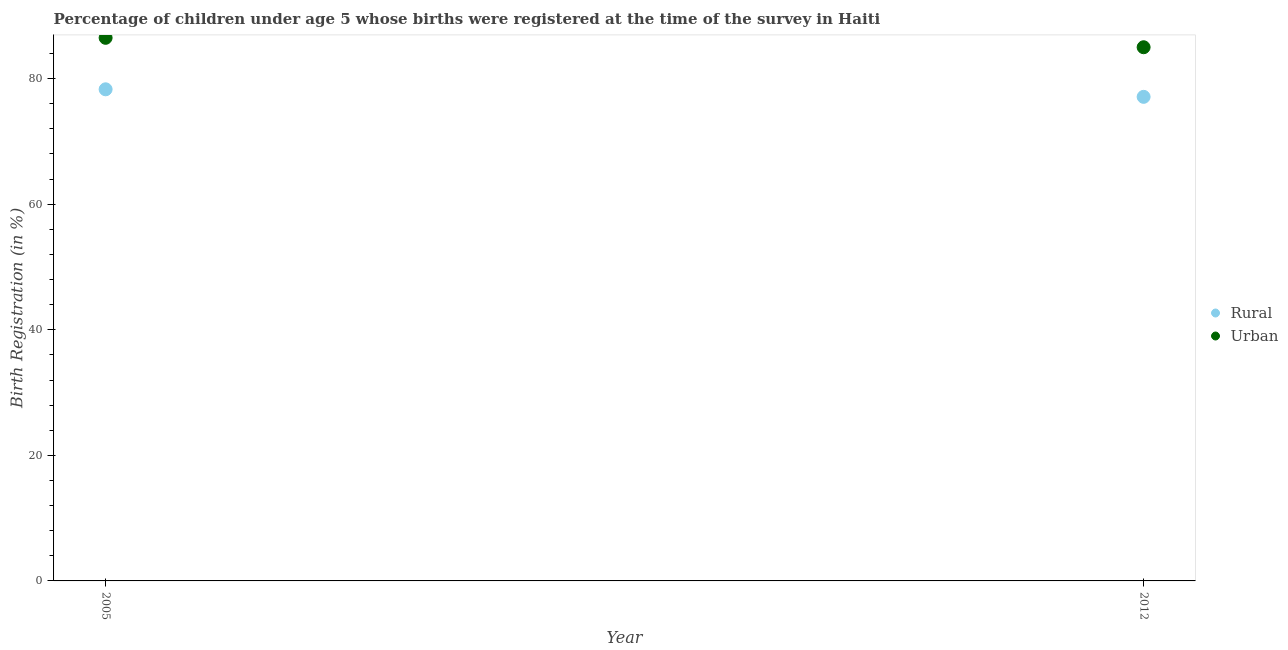Is the number of dotlines equal to the number of legend labels?
Offer a very short reply. Yes. What is the urban birth registration in 2012?
Keep it short and to the point. 85. Across all years, what is the maximum rural birth registration?
Ensure brevity in your answer.  78.3. In which year was the rural birth registration minimum?
Give a very brief answer. 2012. What is the total urban birth registration in the graph?
Provide a short and direct response. 171.5. What is the difference between the urban birth registration in 2005 and that in 2012?
Keep it short and to the point. 1.5. What is the difference between the urban birth registration in 2012 and the rural birth registration in 2005?
Provide a short and direct response. 6.7. What is the average urban birth registration per year?
Provide a succinct answer. 85.75. In the year 2012, what is the difference between the urban birth registration and rural birth registration?
Your response must be concise. 7.9. In how many years, is the rural birth registration greater than 44 %?
Your answer should be very brief. 2. What is the ratio of the rural birth registration in 2005 to that in 2012?
Your answer should be compact. 1.02. Is the rural birth registration in 2005 less than that in 2012?
Keep it short and to the point. No. Does the urban birth registration monotonically increase over the years?
Offer a very short reply. No. Is the rural birth registration strictly greater than the urban birth registration over the years?
Offer a terse response. No. How many years are there in the graph?
Provide a succinct answer. 2. What is the difference between two consecutive major ticks on the Y-axis?
Offer a terse response. 20. Does the graph contain grids?
Provide a succinct answer. No. Where does the legend appear in the graph?
Provide a succinct answer. Center right. How many legend labels are there?
Offer a very short reply. 2. How are the legend labels stacked?
Offer a terse response. Vertical. What is the title of the graph?
Make the answer very short. Percentage of children under age 5 whose births were registered at the time of the survey in Haiti. What is the label or title of the X-axis?
Provide a succinct answer. Year. What is the label or title of the Y-axis?
Offer a terse response. Birth Registration (in %). What is the Birth Registration (in %) of Rural in 2005?
Provide a succinct answer. 78.3. What is the Birth Registration (in %) of Urban in 2005?
Give a very brief answer. 86.5. What is the Birth Registration (in %) of Rural in 2012?
Offer a terse response. 77.1. What is the Birth Registration (in %) in Urban in 2012?
Your answer should be very brief. 85. Across all years, what is the maximum Birth Registration (in %) of Rural?
Make the answer very short. 78.3. Across all years, what is the maximum Birth Registration (in %) of Urban?
Your answer should be compact. 86.5. Across all years, what is the minimum Birth Registration (in %) in Rural?
Keep it short and to the point. 77.1. Across all years, what is the minimum Birth Registration (in %) in Urban?
Your answer should be very brief. 85. What is the total Birth Registration (in %) in Rural in the graph?
Provide a short and direct response. 155.4. What is the total Birth Registration (in %) in Urban in the graph?
Provide a succinct answer. 171.5. What is the difference between the Birth Registration (in %) in Urban in 2005 and that in 2012?
Your answer should be very brief. 1.5. What is the average Birth Registration (in %) in Rural per year?
Your response must be concise. 77.7. What is the average Birth Registration (in %) in Urban per year?
Give a very brief answer. 85.75. In the year 2005, what is the difference between the Birth Registration (in %) in Rural and Birth Registration (in %) in Urban?
Offer a very short reply. -8.2. In the year 2012, what is the difference between the Birth Registration (in %) in Rural and Birth Registration (in %) in Urban?
Your response must be concise. -7.9. What is the ratio of the Birth Registration (in %) of Rural in 2005 to that in 2012?
Ensure brevity in your answer.  1.02. What is the ratio of the Birth Registration (in %) in Urban in 2005 to that in 2012?
Give a very brief answer. 1.02. What is the difference between the highest and the lowest Birth Registration (in %) of Rural?
Ensure brevity in your answer.  1.2. What is the difference between the highest and the lowest Birth Registration (in %) in Urban?
Keep it short and to the point. 1.5. 